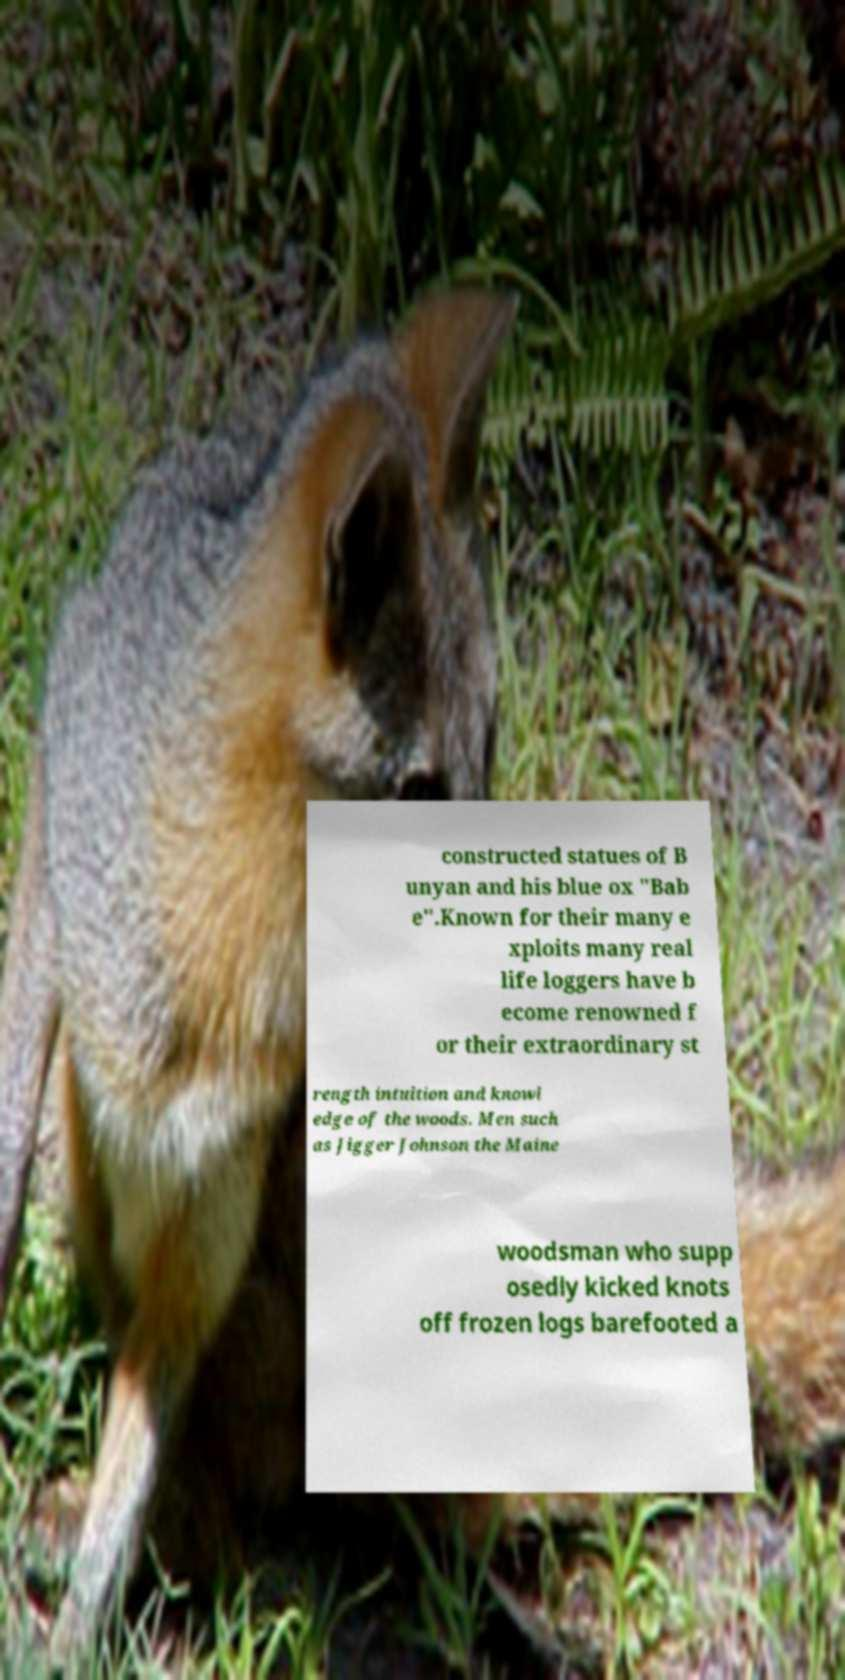What messages or text are displayed in this image? I need them in a readable, typed format. constructed statues of B unyan and his blue ox "Bab e".Known for their many e xploits many real life loggers have b ecome renowned f or their extraordinary st rength intuition and knowl edge of the woods. Men such as Jigger Johnson the Maine woodsman who supp osedly kicked knots off frozen logs barefooted a 